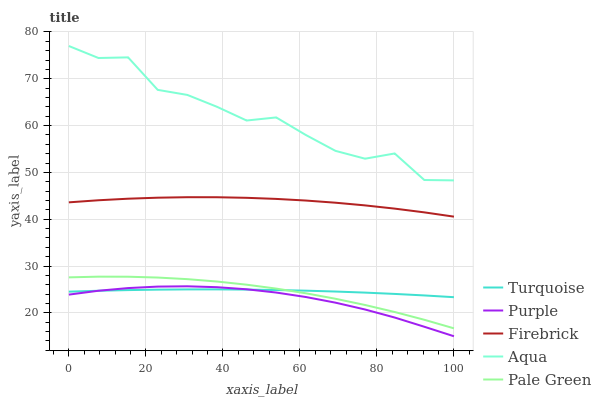Does Purple have the minimum area under the curve?
Answer yes or no. Yes. Does Aqua have the maximum area under the curve?
Answer yes or no. Yes. Does Turquoise have the minimum area under the curve?
Answer yes or no. No. Does Turquoise have the maximum area under the curve?
Answer yes or no. No. Is Turquoise the smoothest?
Answer yes or no. Yes. Is Aqua the roughest?
Answer yes or no. Yes. Is Pale Green the smoothest?
Answer yes or no. No. Is Pale Green the roughest?
Answer yes or no. No. Does Purple have the lowest value?
Answer yes or no. Yes. Does Turquoise have the lowest value?
Answer yes or no. No. Does Aqua have the highest value?
Answer yes or no. Yes. Does Pale Green have the highest value?
Answer yes or no. No. Is Pale Green less than Firebrick?
Answer yes or no. Yes. Is Aqua greater than Purple?
Answer yes or no. Yes. Does Purple intersect Turquoise?
Answer yes or no. Yes. Is Purple less than Turquoise?
Answer yes or no. No. Is Purple greater than Turquoise?
Answer yes or no. No. Does Pale Green intersect Firebrick?
Answer yes or no. No. 